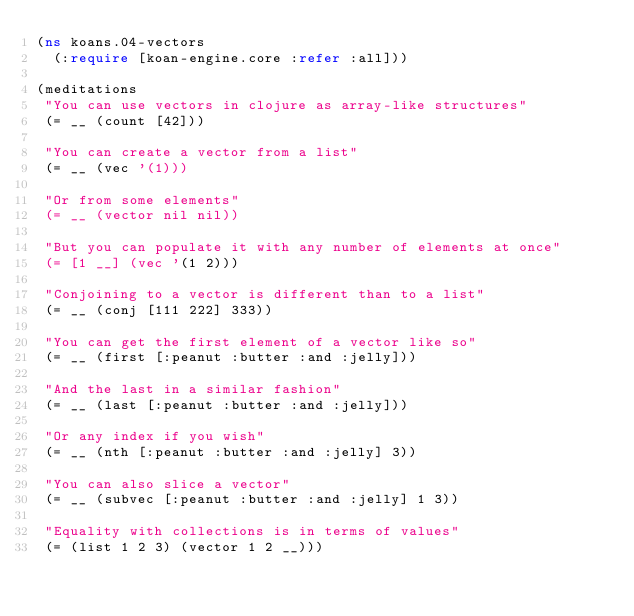Convert code to text. <code><loc_0><loc_0><loc_500><loc_500><_Clojure_>(ns koans.04-vectors
  (:require [koan-engine.core :refer :all]))

(meditations
 "You can use vectors in clojure as array-like structures"
 (= __ (count [42]))

 "You can create a vector from a list"
 (= __ (vec '(1)))

 "Or from some elements"
 (= __ (vector nil nil))

 "But you can populate it with any number of elements at once"
 (= [1 __] (vec '(1 2)))

 "Conjoining to a vector is different than to a list"
 (= __ (conj [111 222] 333))

 "You can get the first element of a vector like so"
 (= __ (first [:peanut :butter :and :jelly]))

 "And the last in a similar fashion"
 (= __ (last [:peanut :butter :and :jelly]))

 "Or any index if you wish"
 (= __ (nth [:peanut :butter :and :jelly] 3))

 "You can also slice a vector"
 (= __ (subvec [:peanut :butter :and :jelly] 1 3))

 "Equality with collections is in terms of values"
 (= (list 1 2 3) (vector 1 2 __)))
</code> 